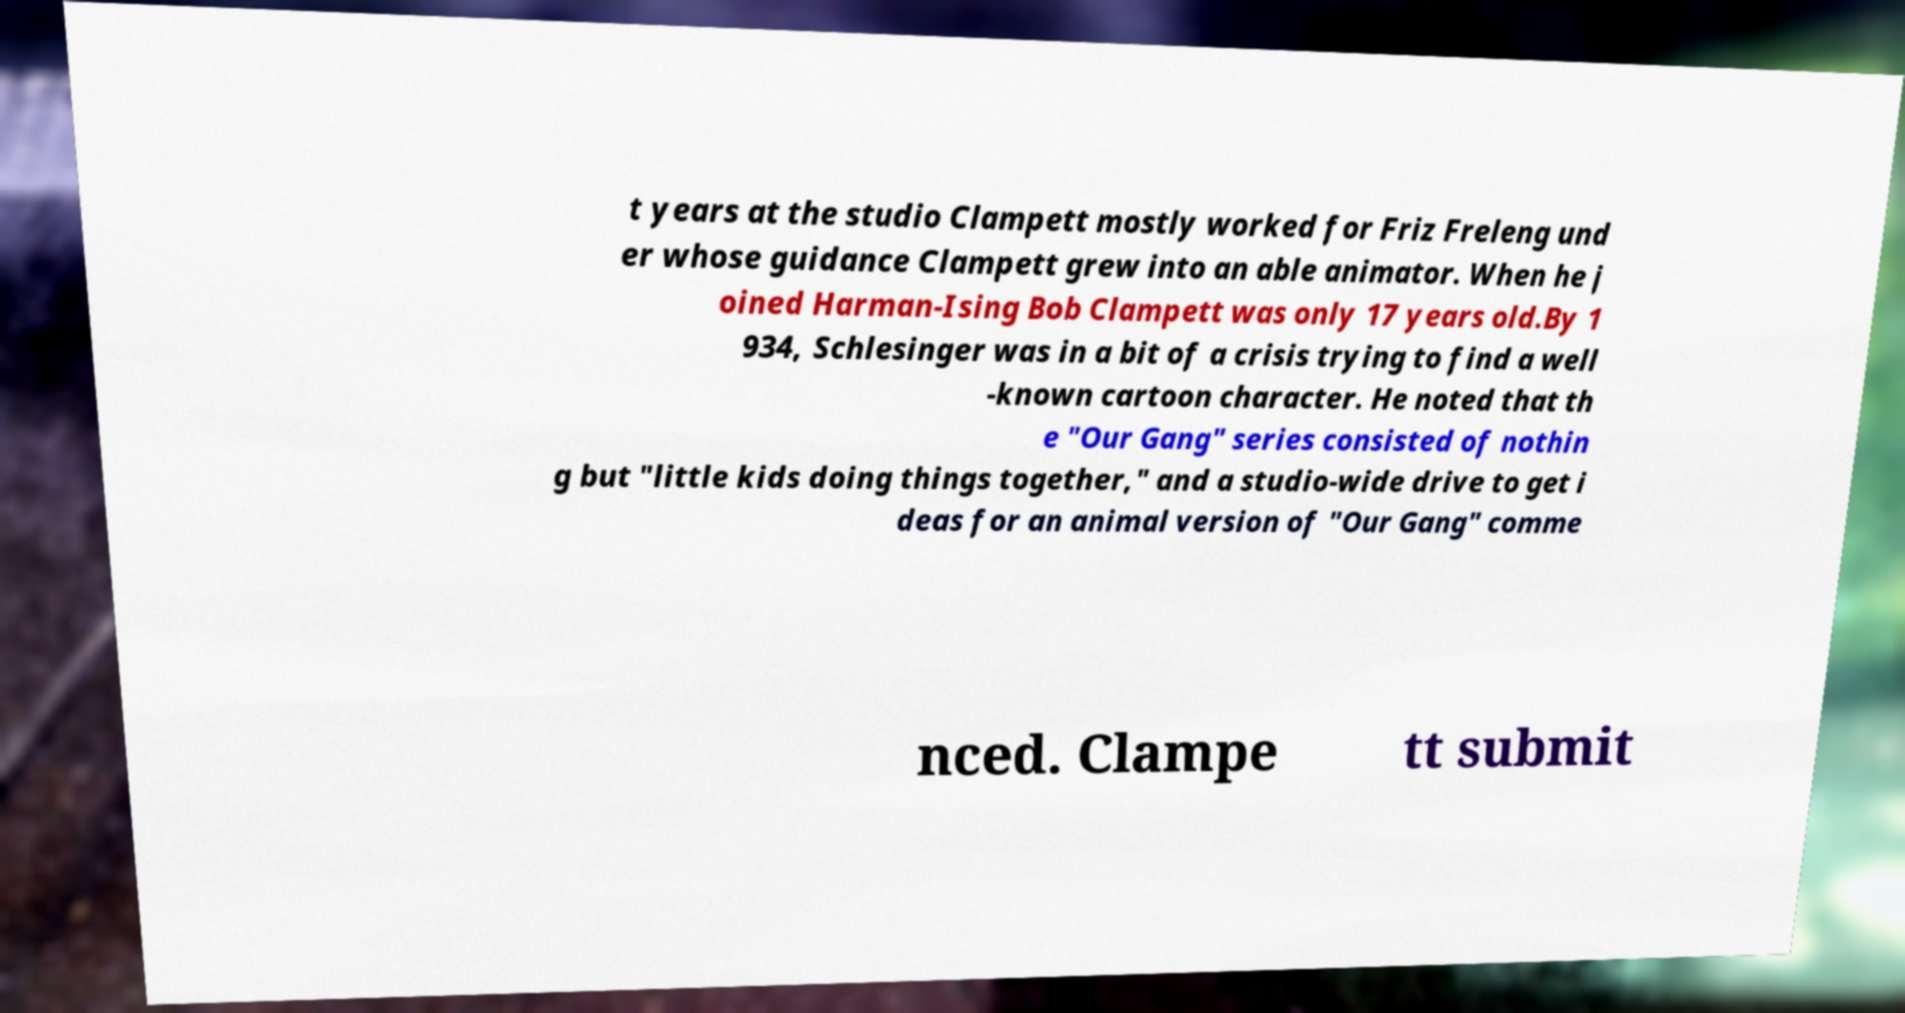For documentation purposes, I need the text within this image transcribed. Could you provide that? t years at the studio Clampett mostly worked for Friz Freleng und er whose guidance Clampett grew into an able animator. When he j oined Harman-Ising Bob Clampett was only 17 years old.By 1 934, Schlesinger was in a bit of a crisis trying to find a well -known cartoon character. He noted that th e "Our Gang" series consisted of nothin g but "little kids doing things together," and a studio-wide drive to get i deas for an animal version of "Our Gang" comme nced. Clampe tt submit 